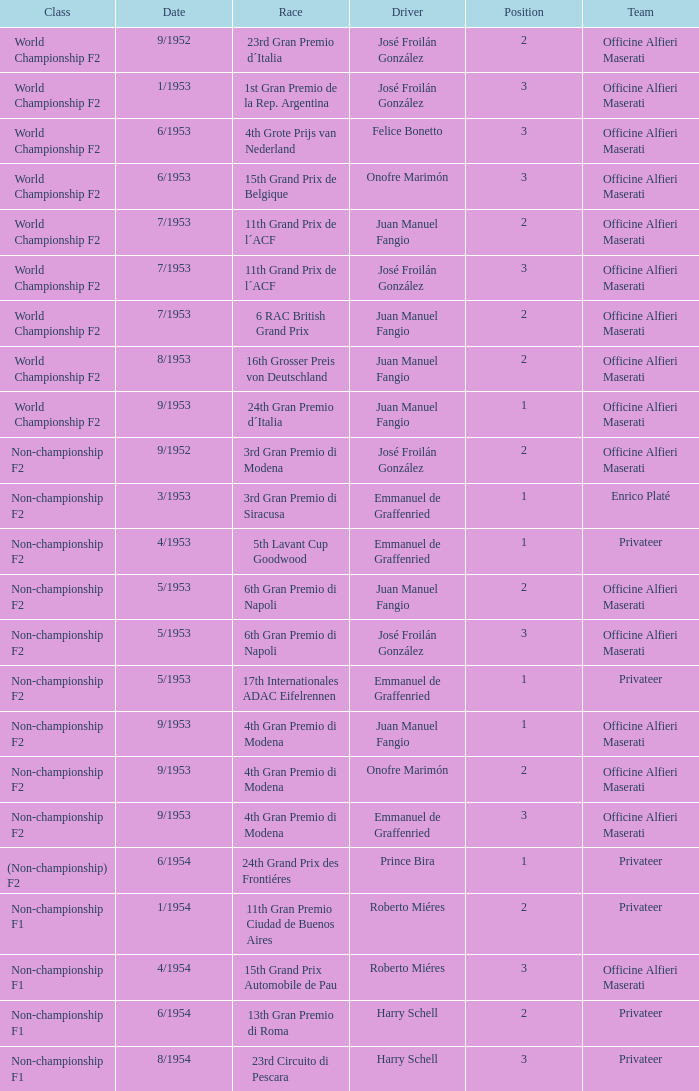Who is the driver in the non-championship f2 class with a position of 2, a date of september 1952, and is part of the officine alfieri maserati team? José Froilán González. 